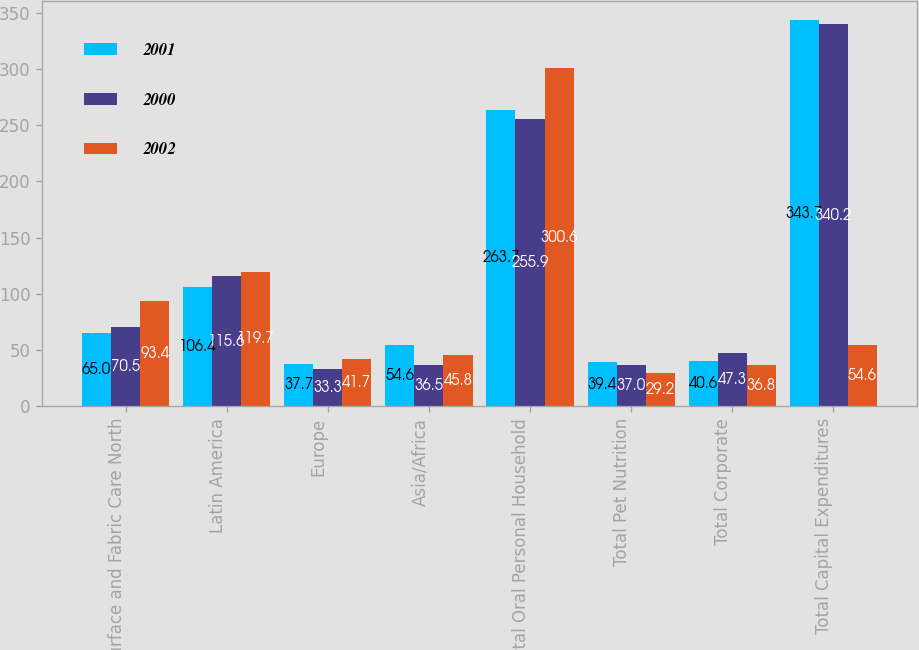Convert chart. <chart><loc_0><loc_0><loc_500><loc_500><stacked_bar_chart><ecel><fcel>Surface and Fabric Care North<fcel>Latin America<fcel>Europe<fcel>Asia/Africa<fcel>Total Oral Personal Household<fcel>Total Pet Nutrition<fcel>Total Corporate<fcel>Total Capital Expenditures<nl><fcel>2001<fcel>65<fcel>106.4<fcel>37.7<fcel>54.6<fcel>263.7<fcel>39.4<fcel>40.6<fcel>343.7<nl><fcel>2000<fcel>70.5<fcel>115.6<fcel>33.3<fcel>36.5<fcel>255.9<fcel>37<fcel>47.3<fcel>340.2<nl><fcel>2002<fcel>93.4<fcel>119.7<fcel>41.7<fcel>45.8<fcel>300.6<fcel>29.2<fcel>36.8<fcel>54.6<nl></chart> 